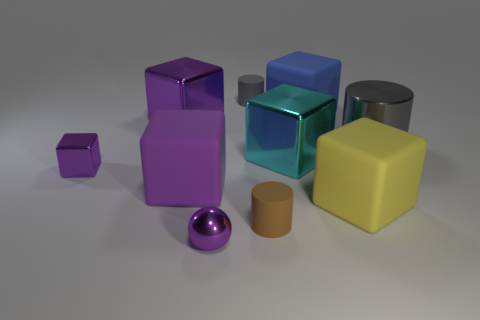There is a small cylinder that is the same color as the large metallic cylinder; what is its material?
Keep it short and to the point. Rubber. What is the color of the tiny thing that is in front of the big gray thing and behind the big purple rubber cube?
Ensure brevity in your answer.  Purple. Is there any other thing of the same color as the big cylinder?
Make the answer very short. Yes. The shiny block that is to the right of the small rubber thing that is behind the large yellow matte block is what color?
Your answer should be compact. Cyan. Do the cyan object and the purple sphere have the same size?
Make the answer very short. No. Are the small purple object that is in front of the tiny brown thing and the tiny cylinder that is in front of the tiny purple cube made of the same material?
Your answer should be compact. No. What shape is the large metal thing on the left side of the tiny cylinder in front of the tiny cylinder that is behind the purple matte object?
Make the answer very short. Cube. Are there more gray things than big cylinders?
Your answer should be compact. Yes. Are there any gray rubber cylinders?
Make the answer very short. Yes. What number of objects are either large objects that are right of the yellow block or big purple blocks that are behind the big cyan cube?
Your answer should be very brief. 2. 